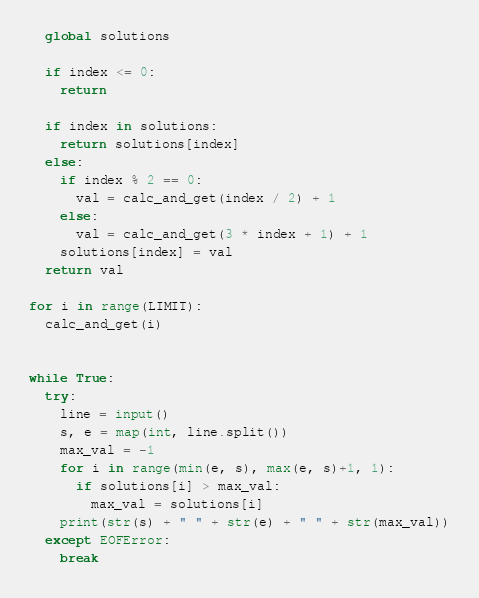<code> <loc_0><loc_0><loc_500><loc_500><_Python_>  global solutions

  if index <= 0:
    return

  if index in solutions:
    return solutions[index]
  else:
    if index % 2 == 0:
      val = calc_and_get(index / 2) + 1
    else:
      val = calc_and_get(3 * index + 1) + 1
    solutions[index] = val
  return val

for i in range(LIMIT):
  calc_and_get(i)


while True:
  try:
    line = input()
    s, e = map(int, line.split())
    max_val = -1
    for i in range(min(e, s), max(e, s)+1, 1):
      if solutions[i] > max_val:
        max_val = solutions[i]
    print(str(s) + " " + str(e) + " " + str(max_val))
  except EOFError:
    break

</code> 